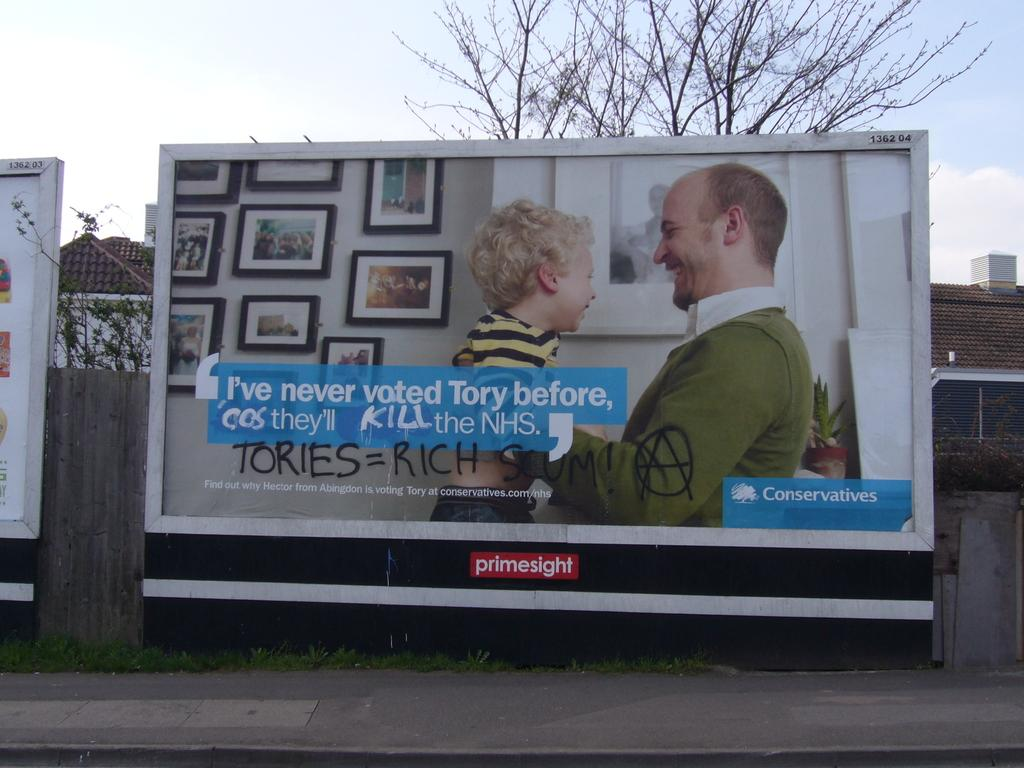Provide a one-sentence caption for the provided image. Someone has vandalized a billboard with the message that tories = rich. 